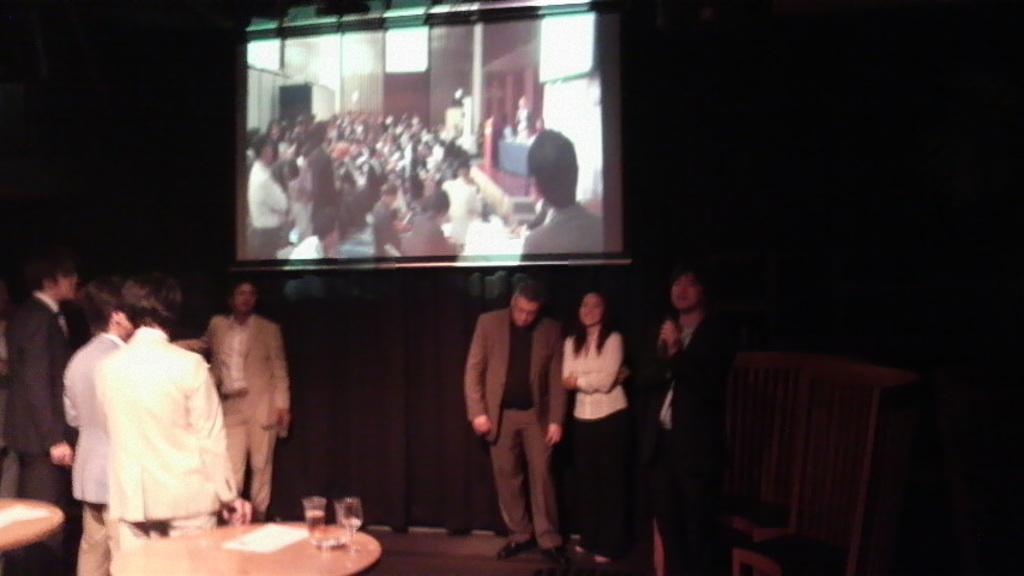How many people are in the image? There is a group of people in the image, but the exact number is not specified. Where are the people standing in the image? The people are standing on a platform in the image. What can be found on the tables in the image? There are glasses and papers on tables in the image. What type of furniture is present in the image? There are chairs in the image. What is the purpose of the screen in the image? The purpose of the screen is not specified, but it is present in the image. What is the color of the background in the image? The background of the image is dark. What type of drug can be seen in the image? There is no drug present in the image. What kind of flame can be seen in the image? There is no flame present in the image. 